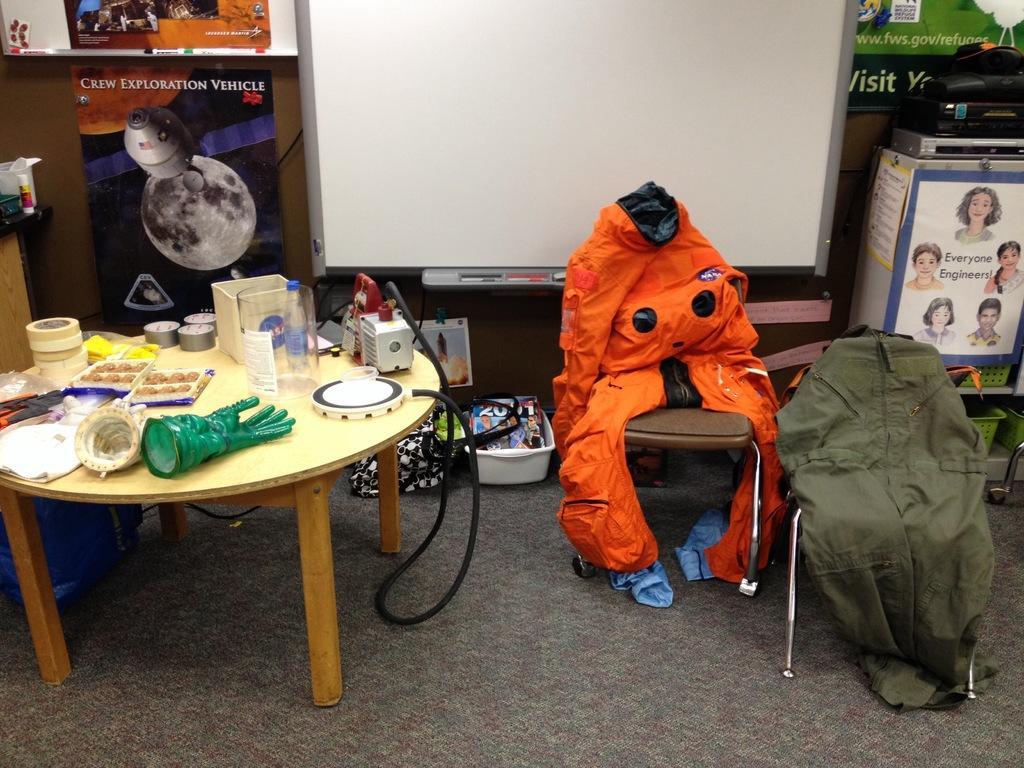Please provide a concise description of this image. In this image there is a dress on the chairs at the right side of the image and at the left side of the image there are food items and gloves and electronic gadgets. 